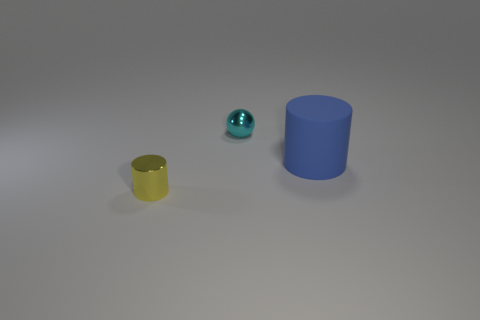Is the number of red rubber blocks greater than the number of big blue objects? No, there are no red rubber blocks present in the image, so the number of red rubber blocks cannot be greater than the number of any objects. There is one large blue cylinder, and it is the only large blue object visible. 